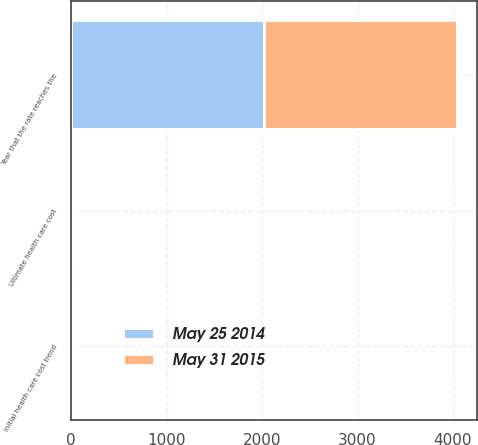<chart> <loc_0><loc_0><loc_500><loc_500><stacked_bar_chart><ecel><fcel>Initial health care cost trend<fcel>Ultimate health care cost<fcel>Year that the rate reaches the<nl><fcel>May 25 2014<fcel>9<fcel>4.5<fcel>2023<nl><fcel>May 31 2015<fcel>10<fcel>5<fcel>2022<nl></chart> 